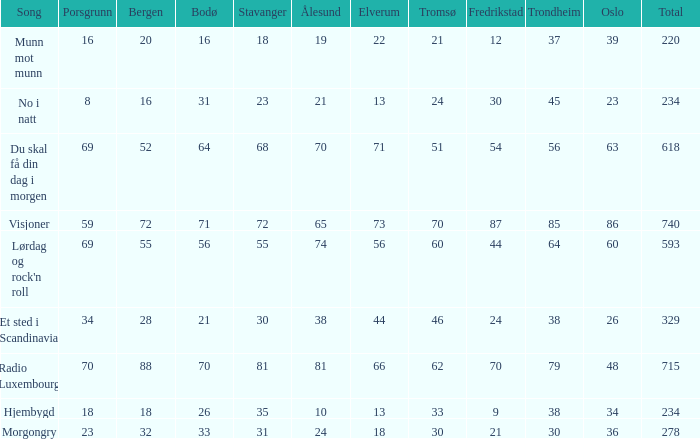What is the lowest total? 220.0. 